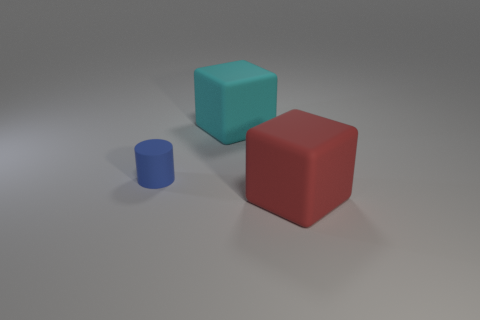Add 1 matte cubes. How many objects exist? 4 Subtract all cylinders. How many objects are left? 2 Subtract all gray balls. How many red cubes are left? 1 Subtract 0 gray cylinders. How many objects are left? 3 Subtract 1 cylinders. How many cylinders are left? 0 Subtract all cyan blocks. Subtract all yellow balls. How many blocks are left? 1 Subtract all large yellow rubber spheres. Subtract all tiny blue matte objects. How many objects are left? 2 Add 2 cyan rubber blocks. How many cyan rubber blocks are left? 3 Add 3 big metal blocks. How many big metal blocks exist? 3 